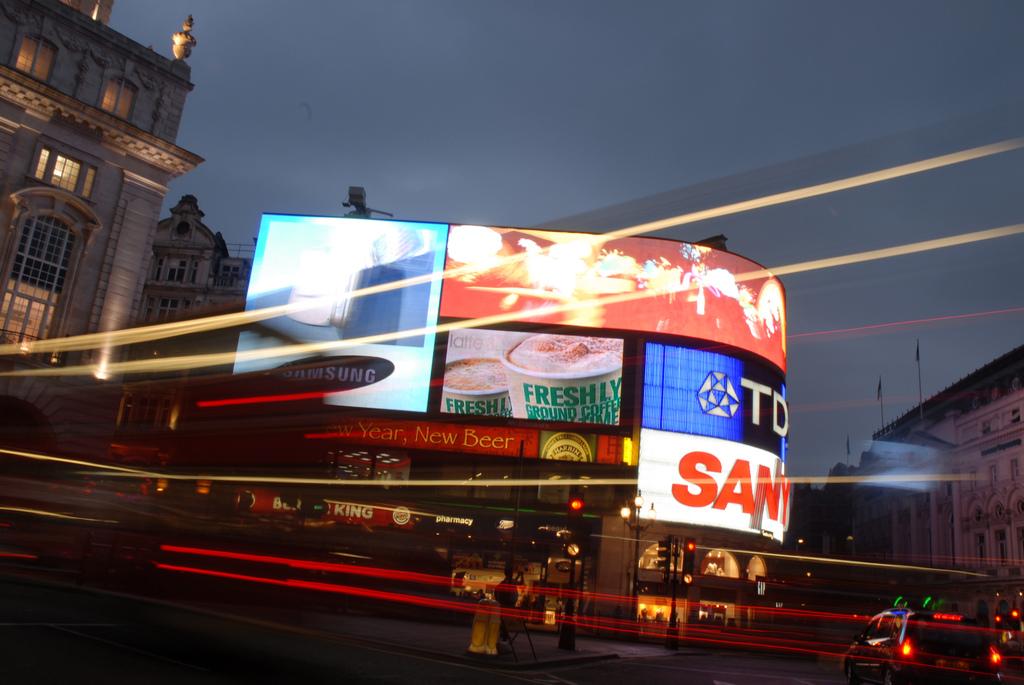Is it new beer?
Give a very brief answer. Yes. 